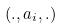<formula> <loc_0><loc_0><loc_500><loc_500>( . , a _ { i } , . )</formula> 